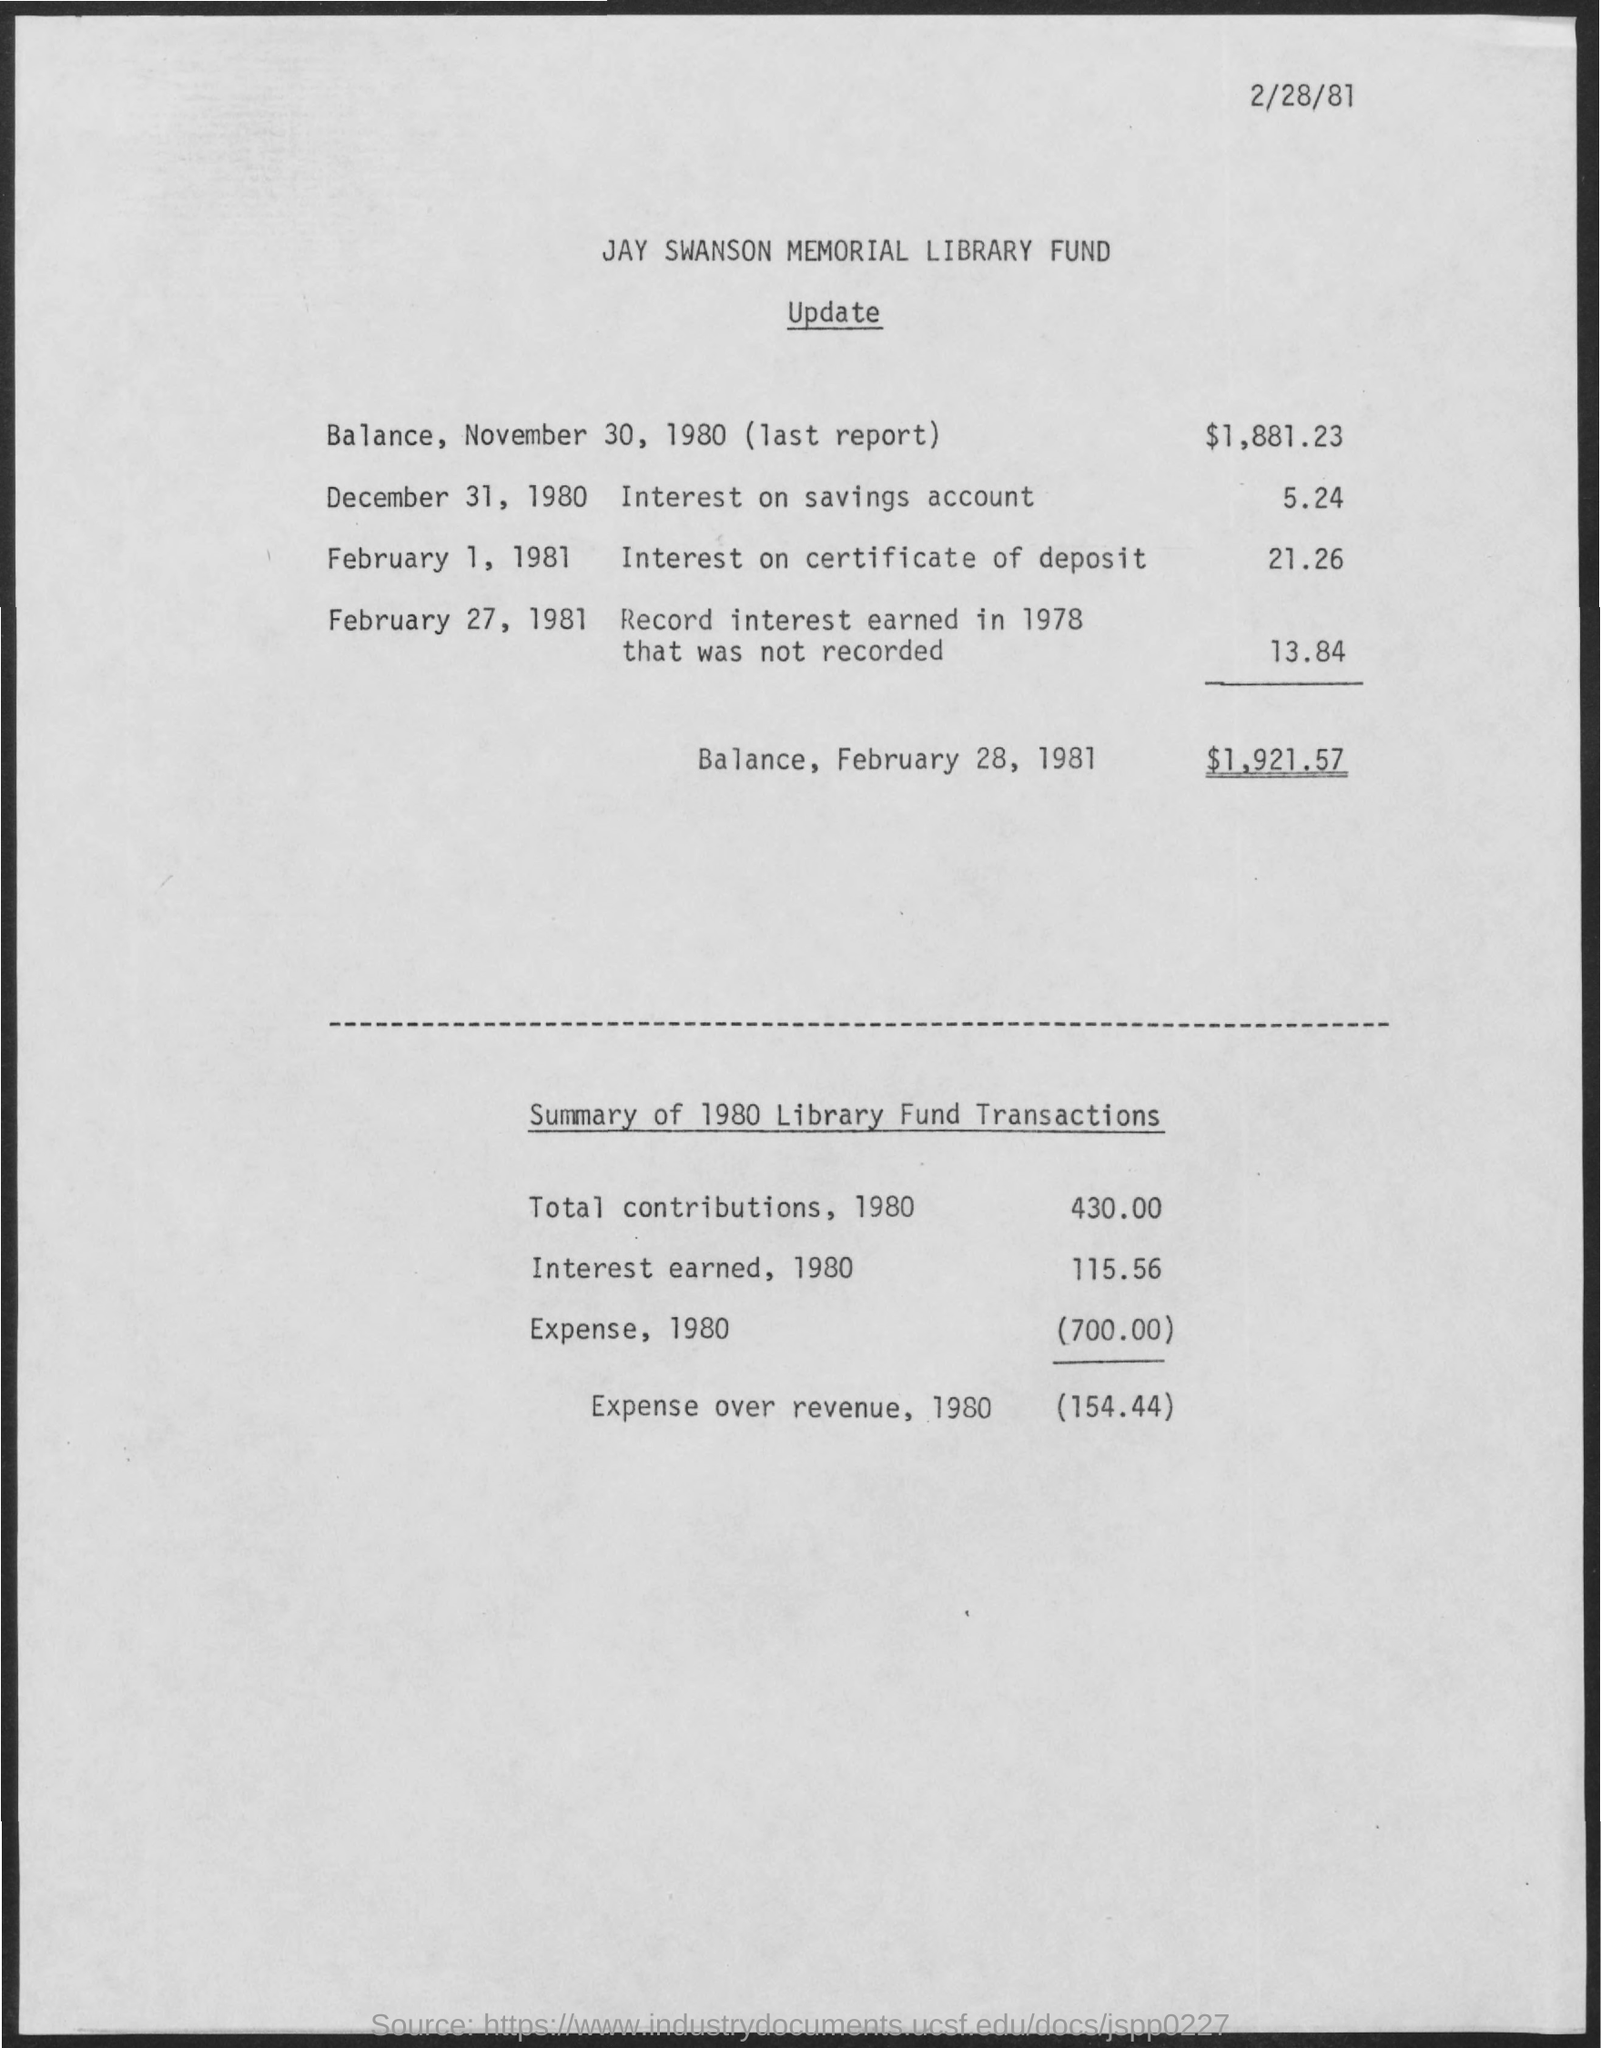Highlight a few significant elements in this photo. The document's first title is the Jay Swanson Memorial Library Fund. 